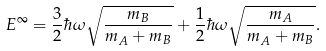<formula> <loc_0><loc_0><loc_500><loc_500>E ^ { \infty } = \frac { 3 } { 2 } \hbar { \omega } \sqrt { \frac { m _ { B } } { m _ { A } + m _ { B } } } + \frac { 1 } { 2 } \hbar { \omega } \sqrt { \frac { m _ { A } } { m _ { A } + m _ { B } } } .</formula> 